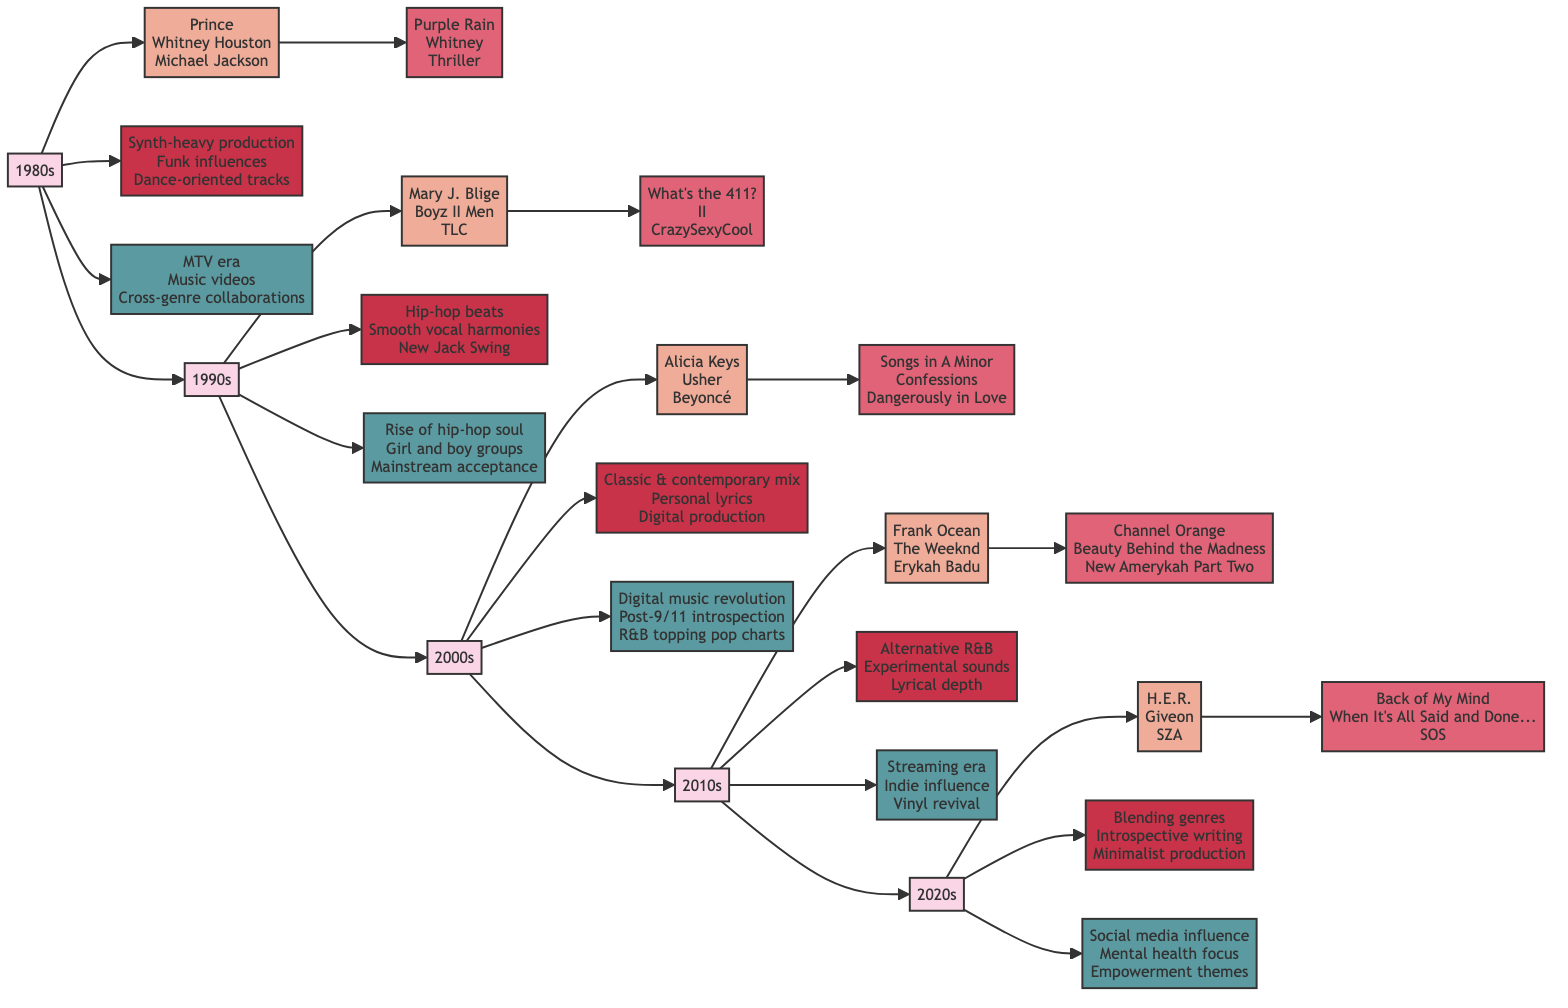What key artists are associated with the 1990s? The 1990s decade node connects to a sub-node with artists listed in bullet points. The key artists are Mary J. Blige, Boyz II Men, and TLC.
Answer: Mary J. Blige, Boyz II Men, TLC How many notable albums are listed for the 2000s? The 2000s decade node connects to a sub-node with three notable albums listed. They are Songs in A Minor, Confessions, and Dangerously in Love. Thus, there are three notable albums.
Answer: 3 What musical feature is shared between the 1980s and 1990s? The 1980s and 1990s both have musical features nodes. The 1980s feature "Synth-heavy production," while the 1990s feature "Hip-hop beats." However, both decades share Funk and Smooth vocal harmonies as a common influence. The specific overlap needs direct inspection of nodes for musical styles that merged in their respective eras.
Answer: Funk influences Which decade introduced the concept of "Alternative R&B"? The 2010s decade node specifically mentions "Alternative R&B" as a musical feature connected to it. Therefore, it is attributed to the 2010s as its defining characteristic.
Answer: 2010s In which decade did the "Digital music revolution" significantly impact R&B? The 2000s decade node outlines "Digital music revolution" as its significant cultural impact. The emphasis on digital production and post-9/11 lyric introspection indicates the transition during that period.
Answer: 2000s What is the cultural significance of the 2020s? The 2020s decade node is connected to cultural aspects that highlight "Social media influence," "Increased focus on mental health," and "Empowerment and activism themes." These cultural elements define the present era in R&B music.
Answer: Social media influence, Increased focus on mental health, Empowerment and activism themes Which notable album correlates with Frank Ocean's representation in the 2010s? The node for the 2010s includes Frank Ocean under key artists. The notable album associated directly with Frank Ocean is "Channel Orange," as listed in the corresponding album node under 2010s.
Answer: Channel Orange What number of key artists are highlighted for the decade of the 2020s? The 2020s decade node connects to a sub-node listing three key artists: H.E.R., Giveon, and SZA. Therefore, the count is three artists specifically given for the current decade in R&B.
Answer: 3 